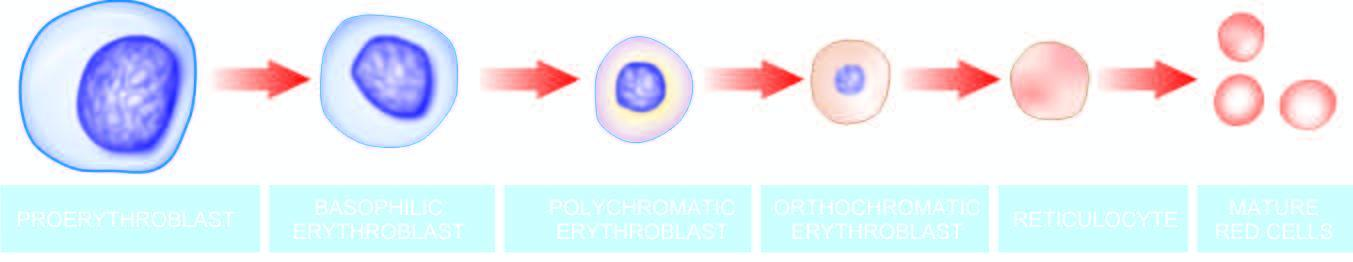what does the cytoplasm contain?
Answer the question using a single word or phrase. Progressively less rna and more haemoglobin 